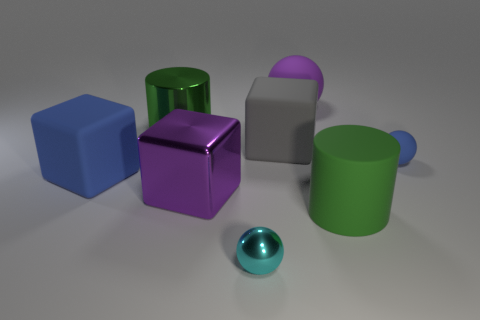Add 2 metallic cubes. How many objects exist? 10 Subtract all blocks. How many objects are left? 5 Add 7 blue metal cylinders. How many blue metal cylinders exist? 7 Subtract 0 green cubes. How many objects are left? 8 Subtract all small shiny spheres. Subtract all tiny blue things. How many objects are left? 6 Add 7 large green metallic things. How many large green metallic things are left? 8 